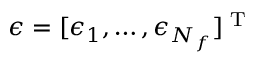Convert formula to latex. <formula><loc_0><loc_0><loc_500><loc_500>\epsilon = [ \epsilon _ { 1 } , \dots , \epsilon _ { N _ { f } } ] ^ { T }</formula> 